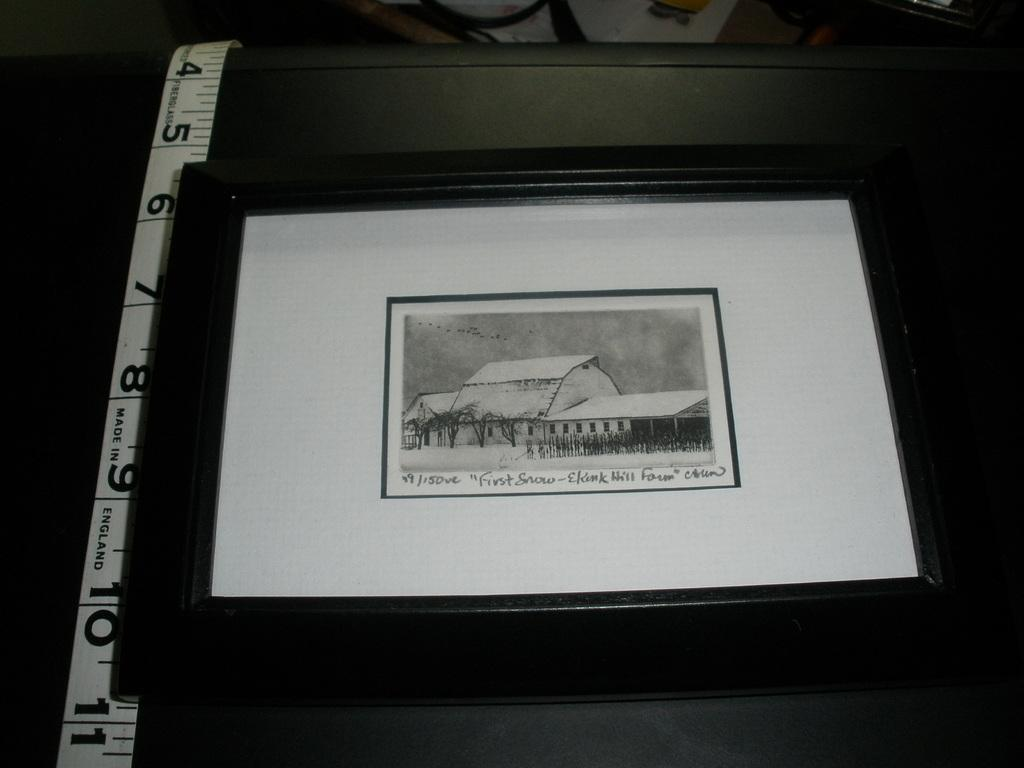<image>
Relay a brief, clear account of the picture shown. A piece of art titled First Snow sits in a black fame near a measuring tape. 